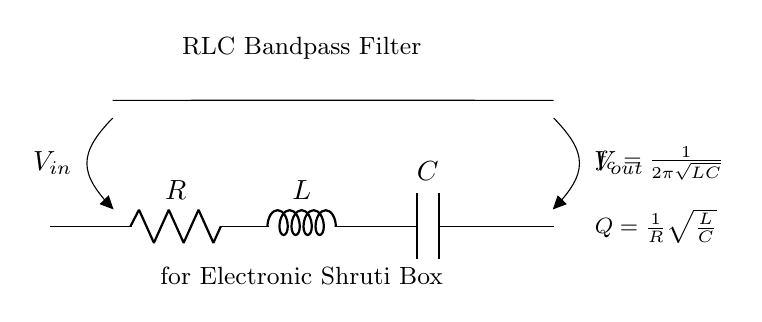What are the components of this circuit? The circuit comprises a resistor, inductor, and capacitor arranged in series. These components are essential to form the RLC bandpass filter.
Answer: Resistor, Inductor, Capacitor What is the purpose of this circuit? The circuit is designed as an RLC bandpass filter to isolate specific harmonic frequencies, typically used in electronic shruti boxes to enhance musical tones.
Answer: Isolating harmonic frequencies What does the symbol Vout represent? Vout represents the output voltage of the circuit, which is measured across the output terminals of the RLC filter.
Answer: Output voltage How is the cutoff frequency calculated? The cutoff frequency formula is provided in the circuit diagram as \(f_c = \frac{1}{2\pi\sqrt{LC}}\). It is derived from the resonant frequency condition of RLC circuits, showing that \(L\) (inductance) and \(C\) (capacitance) together determine where the filter responds most effectively.
Answer: 1 over 2 pi sqrt(LC) What does the Q represent in this circuit? The Q factor, represented as \(Q = \frac{1}{R}\sqrt{\frac{L}{C}}\), indicates the quality or selectivity of the filter. A higher Q indicates a narrower bandwidth, meaning it can isolate frequencies more effectively. This is calculated based on the resistance \(R\), inductance \(L\), and capacitance \(C\).
Answer: Quality factor What configuration is this circuit? The circuit is a series RLC configuration where the resistor, inductor, and capacitor are connected in series. This layout is typical for achieving bandpass filter characteristics.
Answer: Series configuration What role does the resistor play in this circuit? The resistor introduces damping to the circuit, influencing the Q factor, and helps control the bandwidth of the bandpass filter, which ultimately affects how sharply specific frequencies are passed through the filter.
Answer: Damping and bandwidth control 